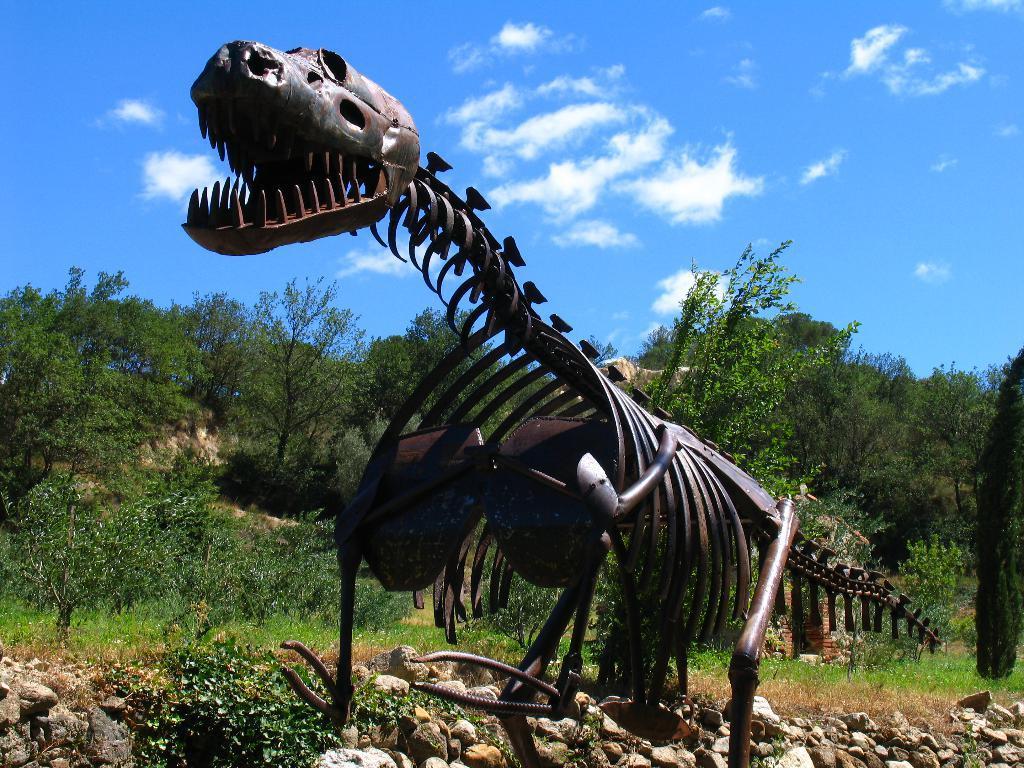Please provide a concise description of this image. In the image in the center we can see one black color dinosaur structure. In the background we can see sky,clouds,trees,plants,grass and stones. 